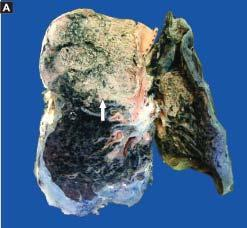what is lying separated from the septal walls by a clear space?
Answer the question using a single word or phrase. The cellular exudates in the alveolar lumina 